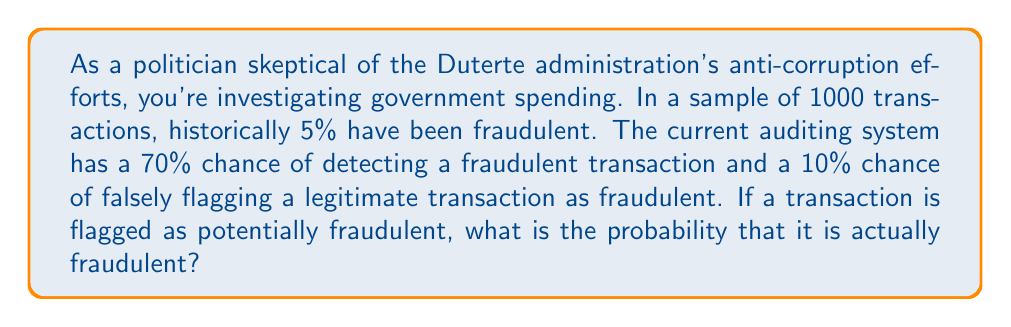What is the answer to this math problem? To solve this problem, we'll use Bayes' Theorem. Let's define our events:

F: The transaction is fraudulent
D: The transaction is detected as fraudulent

We need to find P(F|D), the probability that a transaction is fraudulent given that it was detected as fraudulent.

Bayes' Theorem states:

$$ P(F|D) = \frac{P(D|F) \cdot P(F)}{P(D)} $$

Given:
- P(F) = 0.05 (5% of transactions are fraudulent)
- P(D|F) = 0.70 (70% chance of detecting a fraudulent transaction)
- P(D|not F) = 0.10 (10% chance of falsely flagging a legitimate transaction)

Step 1: Calculate P(D) using the law of total probability:
$$ P(D) = P(D|F) \cdot P(F) + P(D|not F) \cdot P(not F) $$
$$ P(D) = 0.70 \cdot 0.05 + 0.10 \cdot 0.95 = 0.035 + 0.095 = 0.13 $$

Step 2: Apply Bayes' Theorem:
$$ P(F|D) = \frac{0.70 \cdot 0.05}{0.13} = \frac{0.035}{0.13} \approx 0.2692 $$

Therefore, the probability that a flagged transaction is actually fraudulent is approximately 0.2692 or 26.92%.
Answer: The probability that a transaction flagged as potentially fraudulent is actually fraudulent is approximately 0.2692 or 26.92%. 